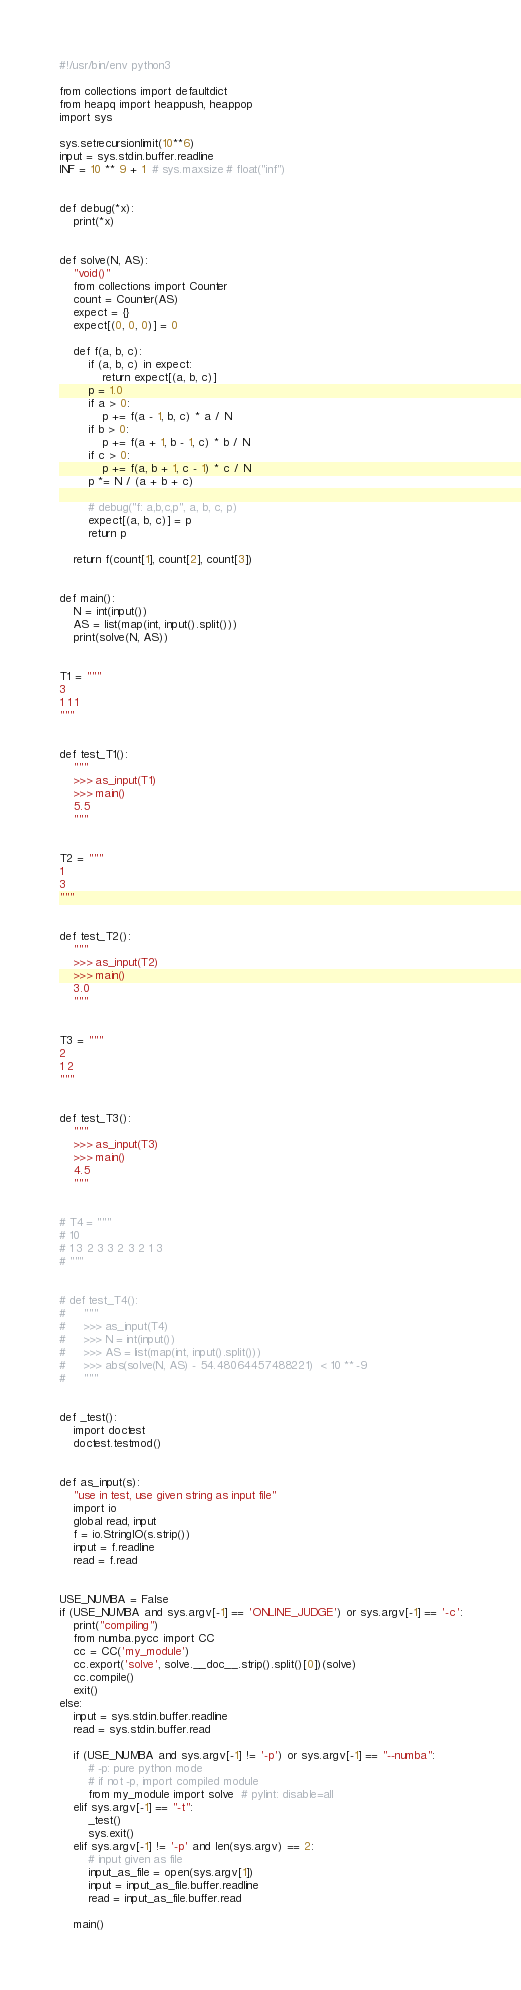<code> <loc_0><loc_0><loc_500><loc_500><_Python_>#!/usr/bin/env python3

from collections import defaultdict
from heapq import heappush, heappop
import sys

sys.setrecursionlimit(10**6)
input = sys.stdin.buffer.readline
INF = 10 ** 9 + 1  # sys.maxsize # float("inf")


def debug(*x):
    print(*x)


def solve(N, AS):
    "void()"
    from collections import Counter
    count = Counter(AS)
    expect = {}
    expect[(0, 0, 0)] = 0

    def f(a, b, c):
        if (a, b, c) in expect:
            return expect[(a, b, c)]
        p = 1.0
        if a > 0:
            p += f(a - 1, b, c) * a / N
        if b > 0:
            p += f(a + 1, b - 1, c) * b / N
        if c > 0:
            p += f(a, b + 1, c - 1) * c / N
        p *= N / (a + b + c)

        # debug("f: a,b,c,p", a, b, c, p)
        expect[(a, b, c)] = p
        return p

    return f(count[1], count[2], count[3])


def main():
    N = int(input())
    AS = list(map(int, input().split()))
    print(solve(N, AS))


T1 = """
3
1 1 1
"""


def test_T1():
    """
    >>> as_input(T1)
    >>> main()
    5.5
    """


T2 = """
1
3
"""


def test_T2():
    """
    >>> as_input(T2)
    >>> main()
    3.0
    """


T3 = """
2
1 2
"""


def test_T3():
    """
    >>> as_input(T3)
    >>> main()
    4.5
    """


# T4 = """
# 10
# 1 3 2 3 3 2 3 2 1 3
# """


# def test_T4():
#     """
#     >>> as_input(T4)
#     >>> N = int(input())
#     >>> AS = list(map(int, input().split()))
#     >>> abs(solve(N, AS) - 54.48064457488221)  < 10 ** -9
#     """


def _test():
    import doctest
    doctest.testmod()


def as_input(s):
    "use in test, use given string as input file"
    import io
    global read, input
    f = io.StringIO(s.strip())
    input = f.readline
    read = f.read


USE_NUMBA = False
if (USE_NUMBA and sys.argv[-1] == 'ONLINE_JUDGE') or sys.argv[-1] == '-c':
    print("compiling")
    from numba.pycc import CC
    cc = CC('my_module')
    cc.export('solve', solve.__doc__.strip().split()[0])(solve)
    cc.compile()
    exit()
else:
    input = sys.stdin.buffer.readline
    read = sys.stdin.buffer.read

    if (USE_NUMBA and sys.argv[-1] != '-p') or sys.argv[-1] == "--numba":
        # -p: pure python mode
        # if not -p, import compiled module
        from my_module import solve  # pylint: disable=all
    elif sys.argv[-1] == "-t":
        _test()
        sys.exit()
    elif sys.argv[-1] != '-p' and len(sys.argv) == 2:
        # input given as file
        input_as_file = open(sys.argv[1])
        input = input_as_file.buffer.readline
        read = input_as_file.buffer.read

    main()
</code> 